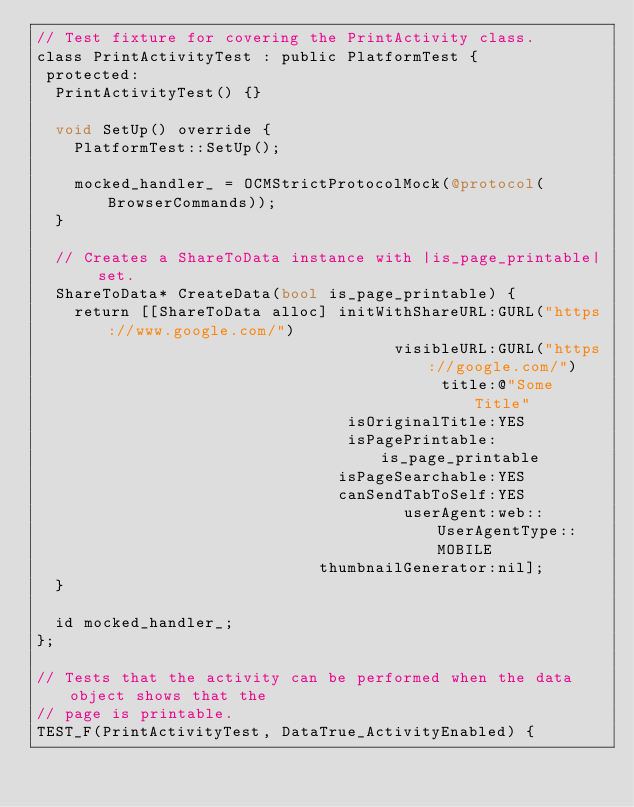<code> <loc_0><loc_0><loc_500><loc_500><_ObjectiveC_>// Test fixture for covering the PrintActivity class.
class PrintActivityTest : public PlatformTest {
 protected:
  PrintActivityTest() {}

  void SetUp() override {
    PlatformTest::SetUp();

    mocked_handler_ = OCMStrictProtocolMock(@protocol(BrowserCommands));
  }

  // Creates a ShareToData instance with |is_page_printable| set.
  ShareToData* CreateData(bool is_page_printable) {
    return [[ShareToData alloc] initWithShareURL:GURL("https://www.google.com/")
                                      visibleURL:GURL("https://google.com/")
                                           title:@"Some Title"
                                 isOriginalTitle:YES
                                 isPagePrintable:is_page_printable
                                isPageSearchable:YES
                                canSendTabToSelf:YES
                                       userAgent:web::UserAgentType::MOBILE
                              thumbnailGenerator:nil];
  }

  id mocked_handler_;
};

// Tests that the activity can be performed when the data object shows that the
// page is printable.
TEST_F(PrintActivityTest, DataTrue_ActivityEnabled) {</code> 